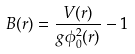<formula> <loc_0><loc_0><loc_500><loc_500>B ( r ) = \frac { V ( r ) } { g \phi _ { 0 } ^ { 2 } ( r ) } - 1</formula> 